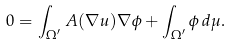Convert formula to latex. <formula><loc_0><loc_0><loc_500><loc_500>0 = \int _ { \Omega ^ { \prime } } A ( \nabla u ) \nabla \phi + \int _ { \Omega ^ { \prime } } \phi \, d \mu .</formula> 